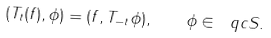Convert formula to latex. <formula><loc_0><loc_0><loc_500><loc_500>( T _ { t } ( f ) , \phi ) = ( f , T _ { - t } \phi ) , \quad \phi \in \ q c S .</formula> 